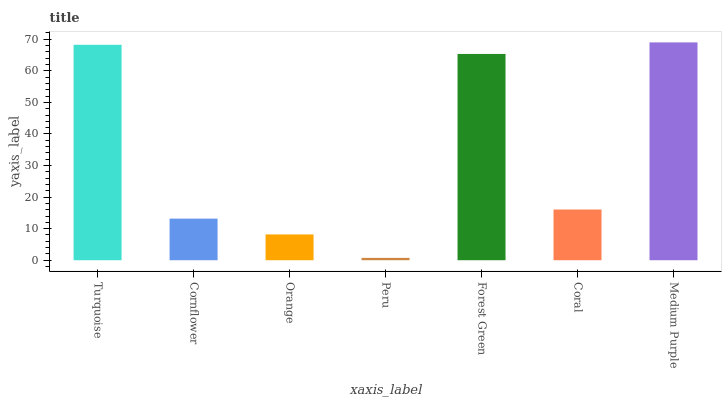Is Peru the minimum?
Answer yes or no. Yes. Is Medium Purple the maximum?
Answer yes or no. Yes. Is Cornflower the minimum?
Answer yes or no. No. Is Cornflower the maximum?
Answer yes or no. No. Is Turquoise greater than Cornflower?
Answer yes or no. Yes. Is Cornflower less than Turquoise?
Answer yes or no. Yes. Is Cornflower greater than Turquoise?
Answer yes or no. No. Is Turquoise less than Cornflower?
Answer yes or no. No. Is Coral the high median?
Answer yes or no. Yes. Is Coral the low median?
Answer yes or no. Yes. Is Cornflower the high median?
Answer yes or no. No. Is Cornflower the low median?
Answer yes or no. No. 